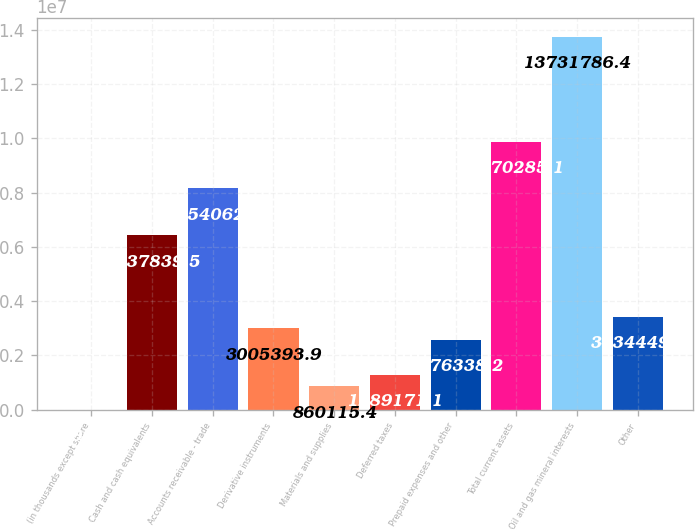Convert chart to OTSL. <chart><loc_0><loc_0><loc_500><loc_500><bar_chart><fcel>(in thousands except share<fcel>Cash and cash equivalents<fcel>Accounts receivable - trade<fcel>Derivative instruments<fcel>Materials and supplies<fcel>Deferred taxes<fcel>Prepaid expenses and other<fcel>Total current assets<fcel>Oil and gas mineral interests<fcel>Other<nl><fcel>2004<fcel>6.43784e+06<fcel>8.15406e+06<fcel>3.00539e+06<fcel>860115<fcel>1.28917e+06<fcel>2.57634e+06<fcel>9.87029e+06<fcel>1.37318e+07<fcel>3.43445e+06<nl></chart> 